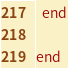<code> <loc_0><loc_0><loc_500><loc_500><_Ruby_>  end
  
end
</code> 